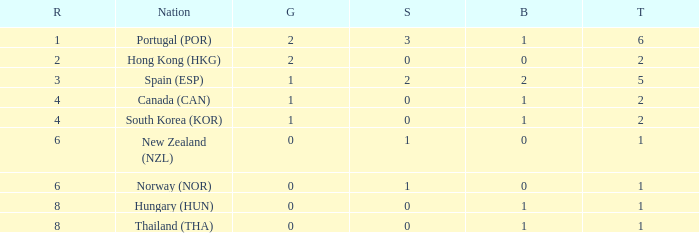What is the lowest Total containing a Bronze of 0 and Rank smaller than 2? None. Help me parse the entirety of this table. {'header': ['R', 'Nation', 'G', 'S', 'B', 'T'], 'rows': [['1', 'Portugal (POR)', '2', '3', '1', '6'], ['2', 'Hong Kong (HKG)', '2', '0', '0', '2'], ['3', 'Spain (ESP)', '1', '2', '2', '5'], ['4', 'Canada (CAN)', '1', '0', '1', '2'], ['4', 'South Korea (KOR)', '1', '0', '1', '2'], ['6', 'New Zealand (NZL)', '0', '1', '0', '1'], ['6', 'Norway (NOR)', '0', '1', '0', '1'], ['8', 'Hungary (HUN)', '0', '0', '1', '1'], ['8', 'Thailand (THA)', '0', '0', '1', '1']]} 